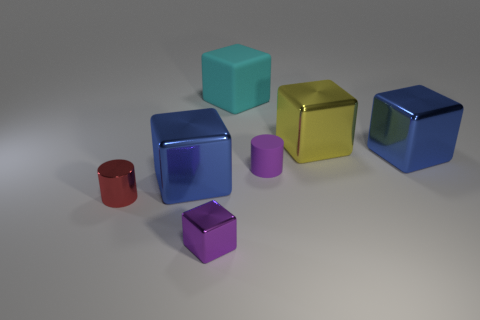There is a matte object that is the same color as the small cube; what shape is it?
Make the answer very short. Cylinder. Is there a small cylinder that has the same color as the tiny shiny cube?
Make the answer very short. Yes. What number of metallic blocks are on the left side of the yellow shiny cube and on the right side of the big matte thing?
Your response must be concise. 0. How many other things are there of the same size as the purple rubber cylinder?
Provide a short and direct response. 2. There is a small thing to the right of the tiny shiny cube; is it the same shape as the small object that is left of the small purple cube?
Ensure brevity in your answer.  Yes. How many objects are small metallic blocks or rubber cylinders that are on the right side of the big matte block?
Ensure brevity in your answer.  2. There is a tiny object that is to the left of the cyan matte block and behind the tiny block; what material is it?
Ensure brevity in your answer.  Metal. What is the color of the tiny cube that is the same material as the red thing?
Make the answer very short. Purple. What number of things are either cyan matte things or metallic things?
Your response must be concise. 6. There is a red shiny thing; does it have the same size as the purple thing right of the big cyan rubber thing?
Ensure brevity in your answer.  Yes. 